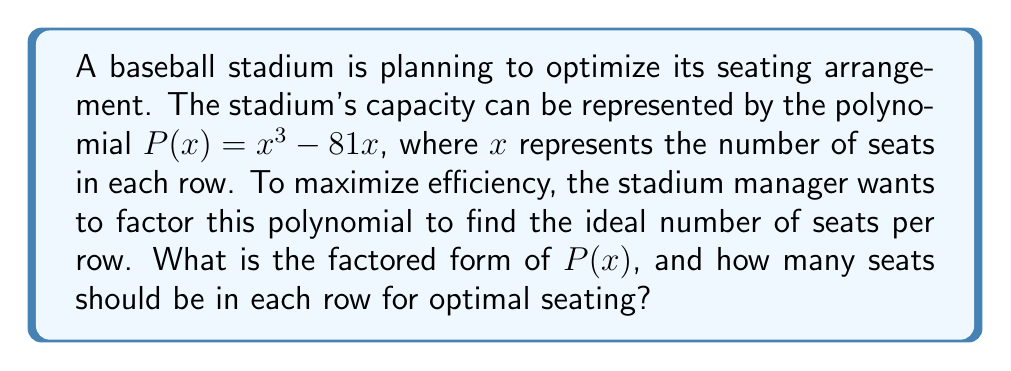Give your solution to this math problem. Let's approach this step-by-step:

1) We start with the polynomial $P(x) = x^3 - 81x$

2) We can factor out the greatest common factor:
   $P(x) = x(x^2 - 81)$

3) The expression inside the parentheses, $x^2 - 81$, is a difference of squares. We can factor it further:
   $x^2 - 81 = (x+9)(x-9)$

4) Combining steps 2 and 3, we get the fully factored form:
   $P(x) = x(x+9)(x-9)$

5) To find the optimal number of seats per row, we need to find the roots of this polynomial. The roots are the values of $x$ where $P(x) = 0$. From the factored form, we can see that $P(x) = 0$ when:
   $x = 0$, or $x = 9$, or $x = -9$

6) Since we're dealing with seating, we can discard the negative solution. Between 0 and 9 seats per row, 9 would be more efficient.

Therefore, the optimal number of seats per row is 9.
Answer: The factored form of $P(x)$ is $x(x+9)(x-9)$, and the optimal number of seats per row is 9. 